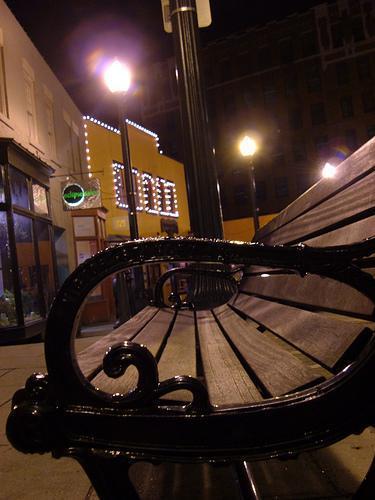How many lamps are lit up?
Give a very brief answer. 3. 